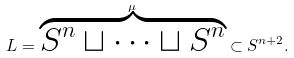<formula> <loc_0><loc_0><loc_500><loc_500>L = \overbrace { S ^ { n } \sqcup \cdots \sqcup S ^ { n } } ^ { \mu } \subset S ^ { n + 2 } .</formula> 